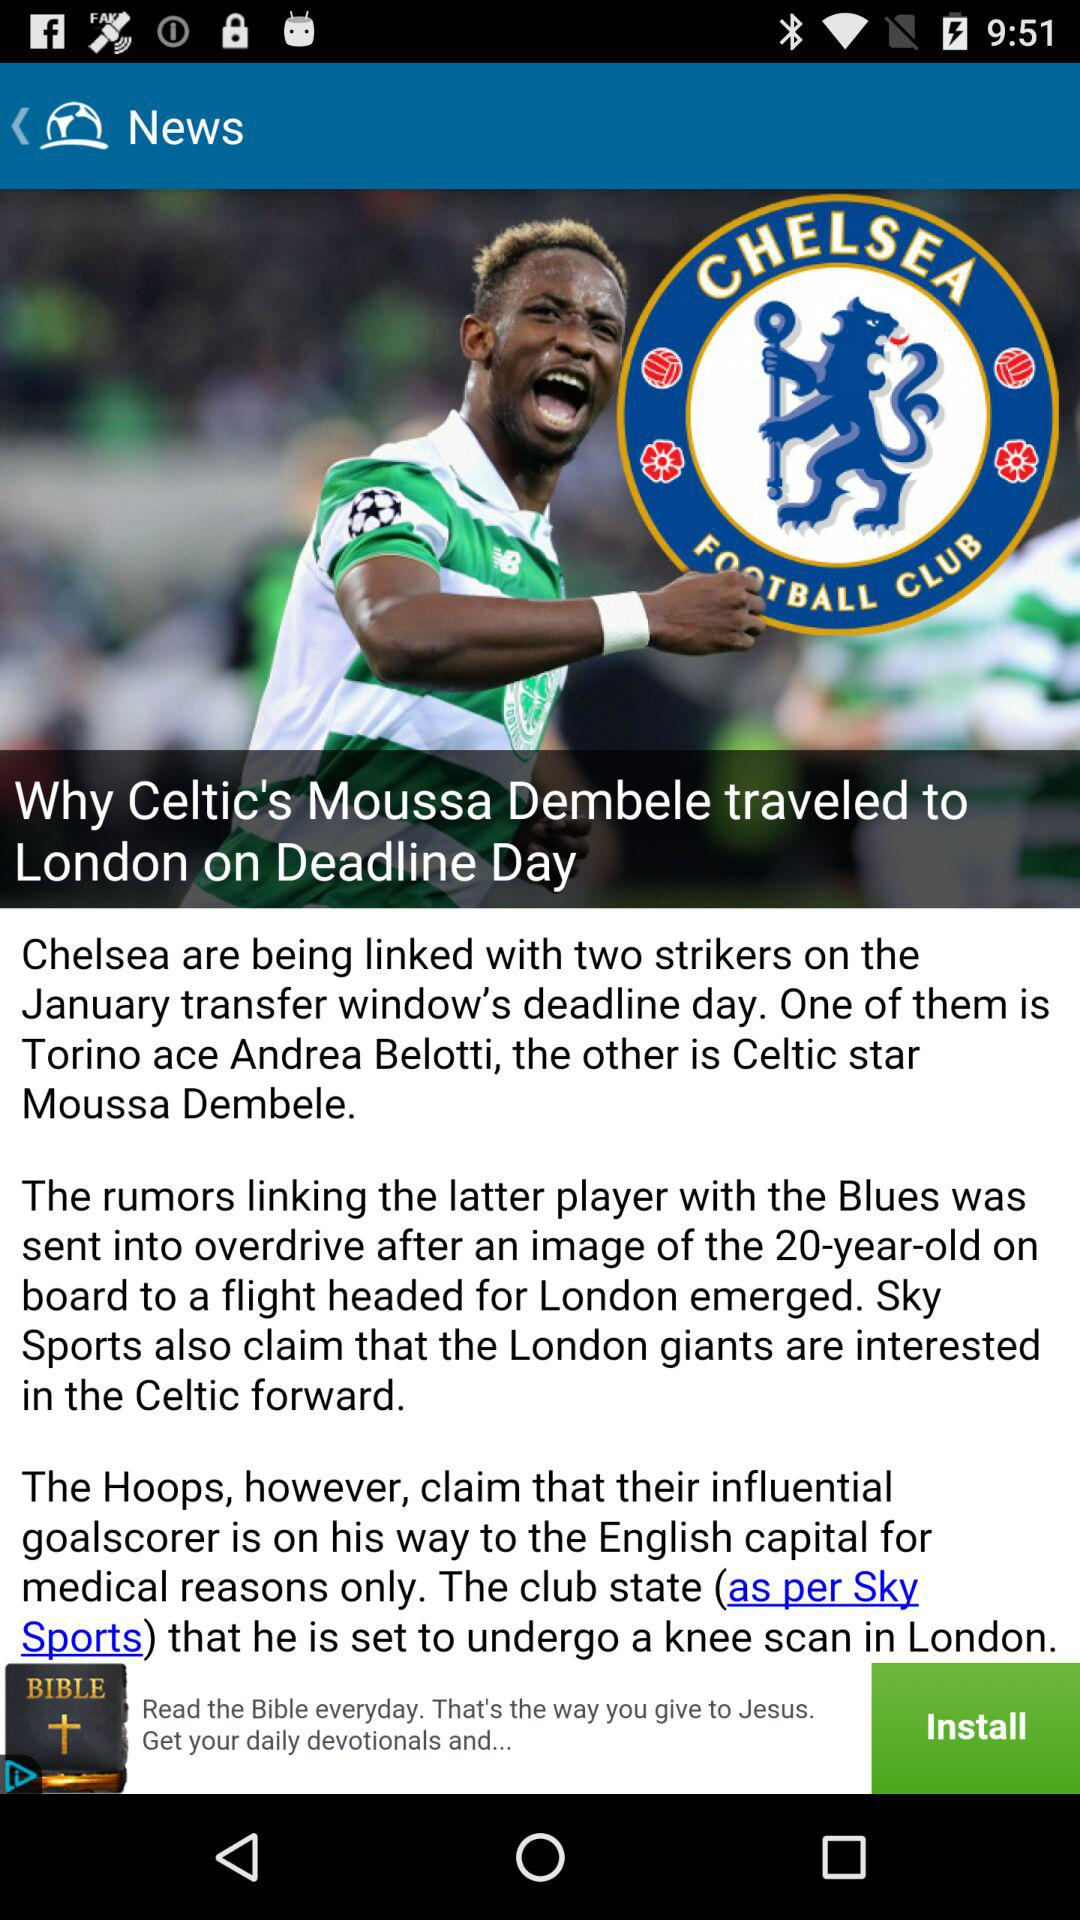What is the title of the article? The title is "Why Celtic's Moussa Dembele traveled to London on Deadline Day". 